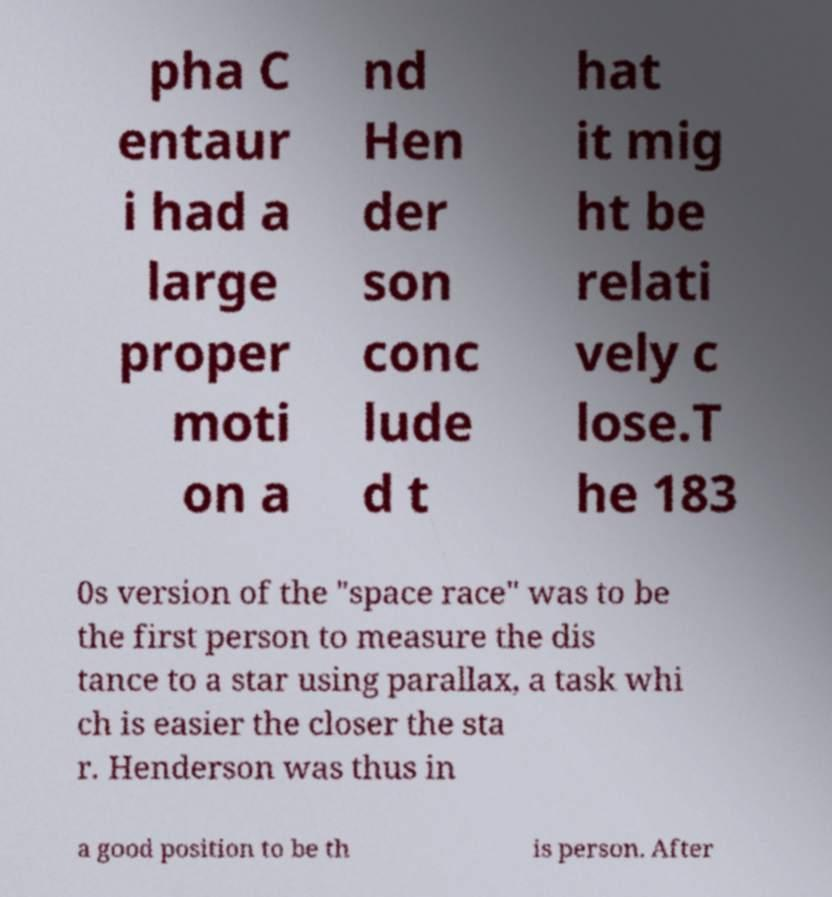Can you accurately transcribe the text from the provided image for me? pha C entaur i had a large proper moti on a nd Hen der son conc lude d t hat it mig ht be relati vely c lose.T he 183 0s version of the "space race" was to be the first person to measure the dis tance to a star using parallax, a task whi ch is easier the closer the sta r. Henderson was thus in a good position to be th is person. After 